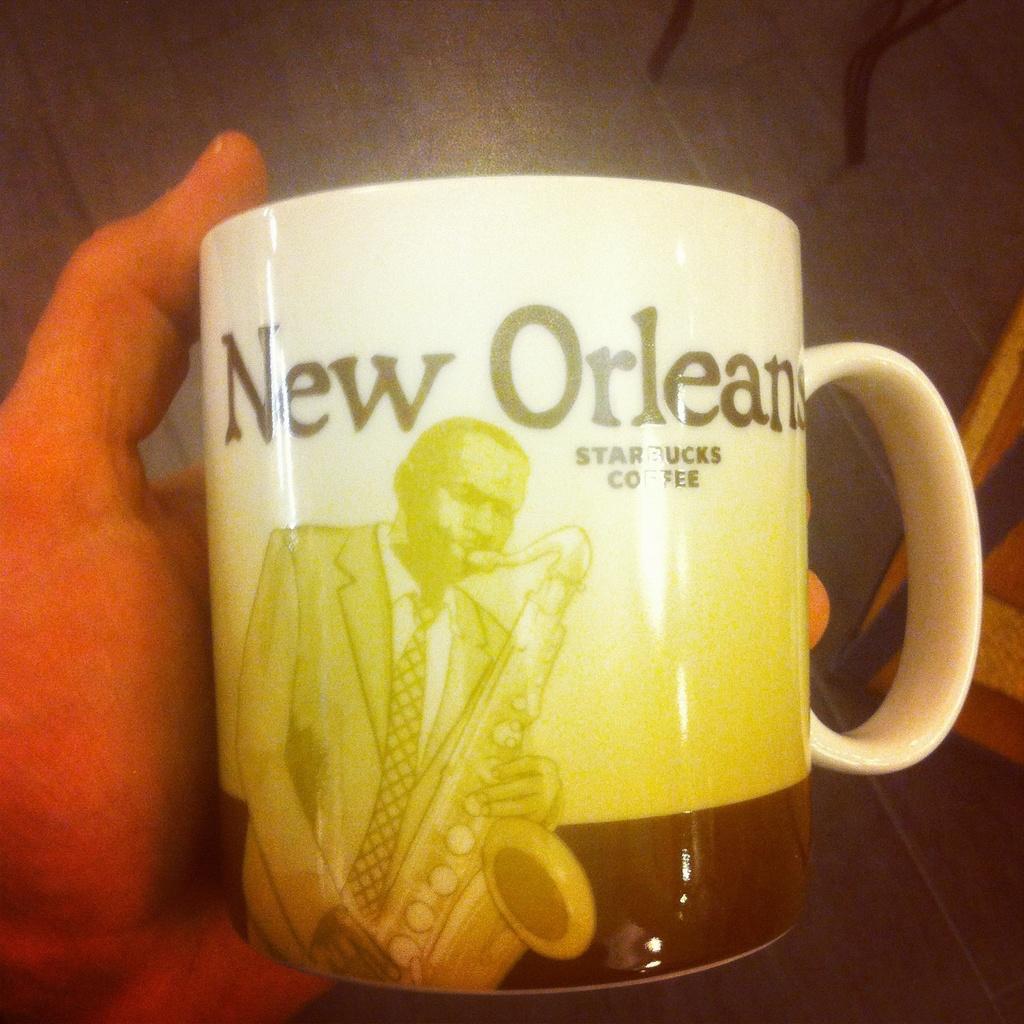What us city is mentioned on the coffee mug?
Offer a very short reply. New orleans. What coffee company is on the mug?
Ensure brevity in your answer.  Starbucks. 